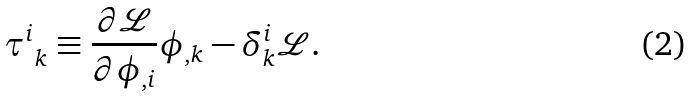Convert formula to latex. <formula><loc_0><loc_0><loc_500><loc_500>\tau ^ { i } _ { \ k } \equiv \frac { \partial \mathcal { L } } { \partial \phi _ { , i } } \phi _ { , k } - \delta ^ { i } _ { k } \mathcal { L } .</formula> 